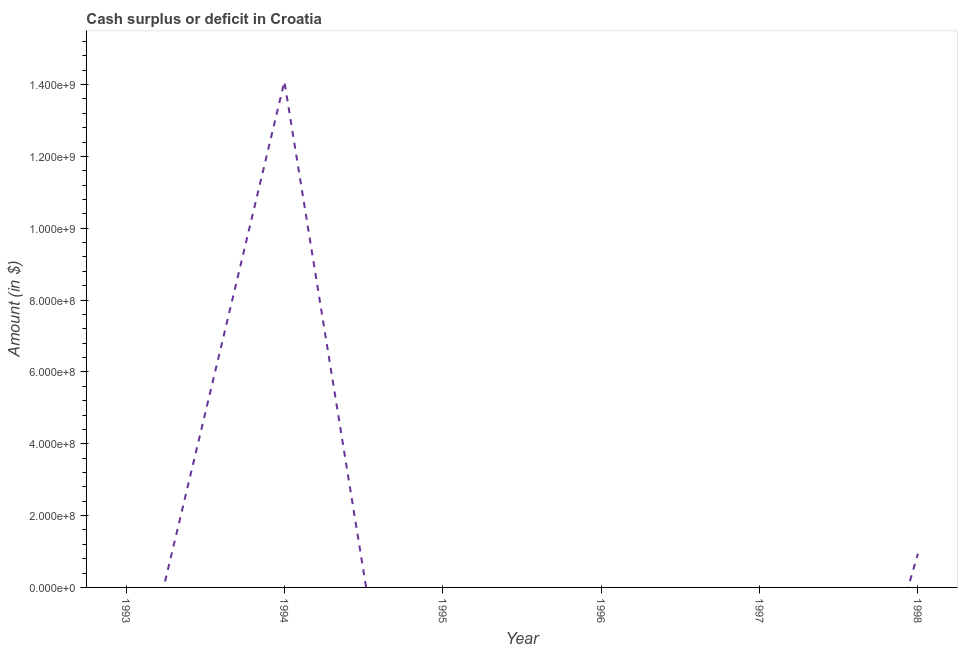What is the cash surplus or deficit in 1993?
Offer a very short reply. 0. Across all years, what is the maximum cash surplus or deficit?
Give a very brief answer. 1.41e+09. Across all years, what is the minimum cash surplus or deficit?
Provide a short and direct response. 0. In which year was the cash surplus or deficit maximum?
Your answer should be compact. 1994. What is the sum of the cash surplus or deficit?
Offer a very short reply. 1.50e+09. What is the difference between the cash surplus or deficit in 1994 and 1998?
Provide a short and direct response. 1.31e+09. What is the average cash surplus or deficit per year?
Keep it short and to the point. 2.50e+08. What is the ratio of the cash surplus or deficit in 1994 to that in 1998?
Offer a terse response. 14.99. What is the difference between the highest and the lowest cash surplus or deficit?
Give a very brief answer. 1.41e+09. How many years are there in the graph?
Make the answer very short. 6. What is the difference between two consecutive major ticks on the Y-axis?
Make the answer very short. 2.00e+08. Does the graph contain grids?
Keep it short and to the point. No. What is the title of the graph?
Give a very brief answer. Cash surplus or deficit in Croatia. What is the label or title of the X-axis?
Provide a succinct answer. Year. What is the label or title of the Y-axis?
Make the answer very short. Amount (in $). What is the Amount (in $) of 1994?
Make the answer very short. 1.41e+09. What is the Amount (in $) in 1998?
Your answer should be compact. 9.39e+07. What is the difference between the Amount (in $) in 1994 and 1998?
Offer a very short reply. 1.31e+09. What is the ratio of the Amount (in $) in 1994 to that in 1998?
Your response must be concise. 14.99. 